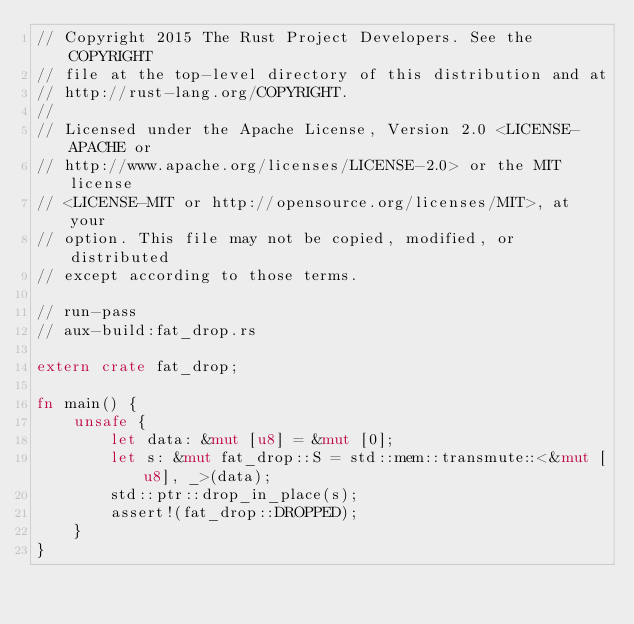<code> <loc_0><loc_0><loc_500><loc_500><_Rust_>// Copyright 2015 The Rust Project Developers. See the COPYRIGHT
// file at the top-level directory of this distribution and at
// http://rust-lang.org/COPYRIGHT.
//
// Licensed under the Apache License, Version 2.0 <LICENSE-APACHE or
// http://www.apache.org/licenses/LICENSE-2.0> or the MIT license
// <LICENSE-MIT or http://opensource.org/licenses/MIT>, at your
// option. This file may not be copied, modified, or distributed
// except according to those terms.

// run-pass
// aux-build:fat_drop.rs

extern crate fat_drop;

fn main() {
    unsafe {
        let data: &mut [u8] = &mut [0];
        let s: &mut fat_drop::S = std::mem::transmute::<&mut [u8], _>(data);
        std::ptr::drop_in_place(s);
        assert!(fat_drop::DROPPED);
    }
}
</code> 